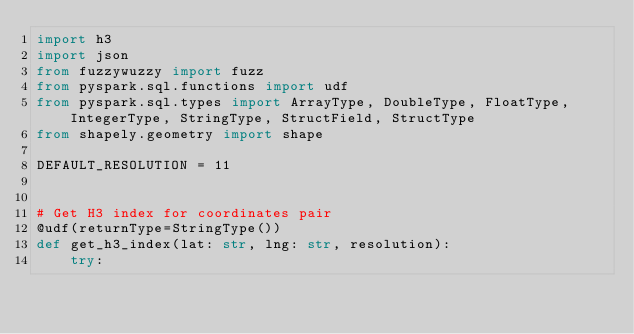<code> <loc_0><loc_0><loc_500><loc_500><_Python_>import h3
import json
from fuzzywuzzy import fuzz
from pyspark.sql.functions import udf
from pyspark.sql.types import ArrayType, DoubleType, FloatType, IntegerType, StringType, StructField, StructType
from shapely.geometry import shape

DEFAULT_RESOLUTION = 11


# Get H3 index for coordinates pair
@udf(returnType=StringType())
def get_h3_index(lat: str, lng: str, resolution):
    try:</code> 